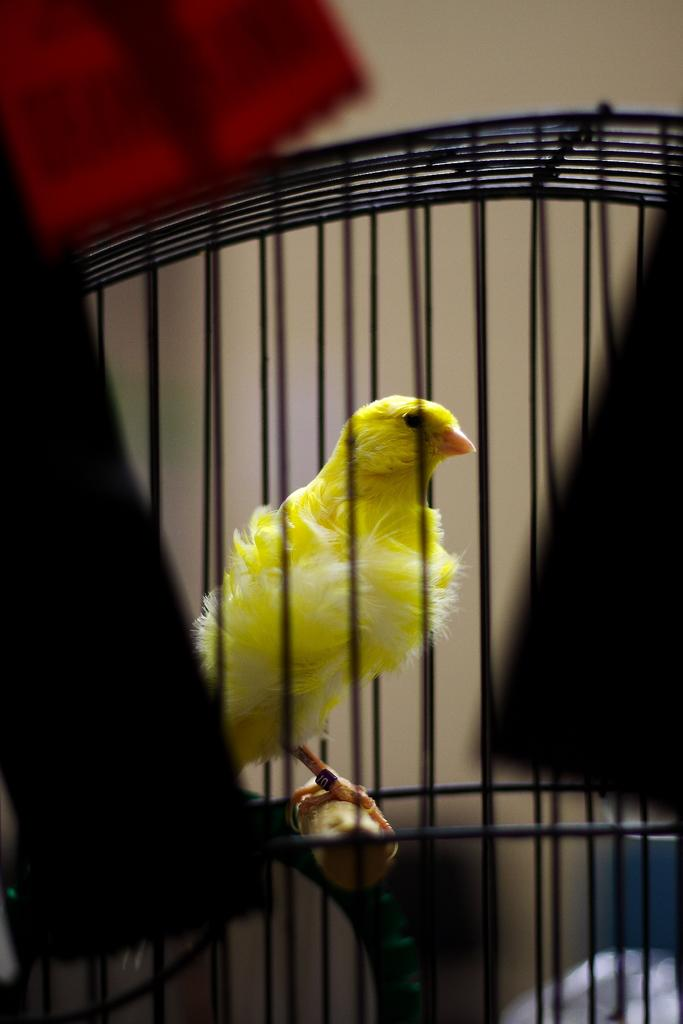What type of animal is in the image? There is a bird in the image. Where is the bird located? The bird is in a cage. What type of order is the bird following in the image? There is no indication of any order being followed by the bird in the image. 